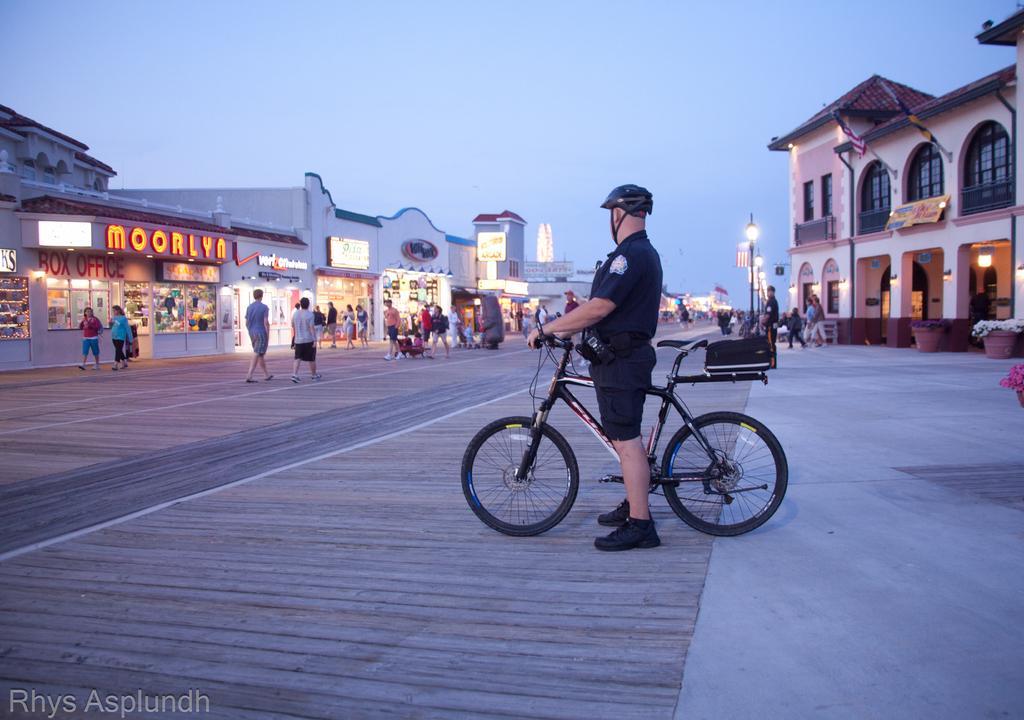How would you summarize this image in a sentence or two? As we can see in the image there are buildings, few people there and there, lights, a man holding bicycle and on the top there is sky. 